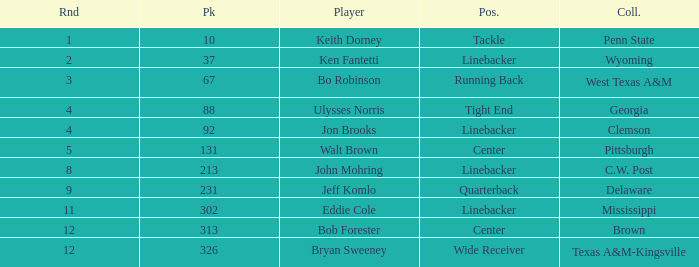What is the college pick for 213? C.W. Post. 